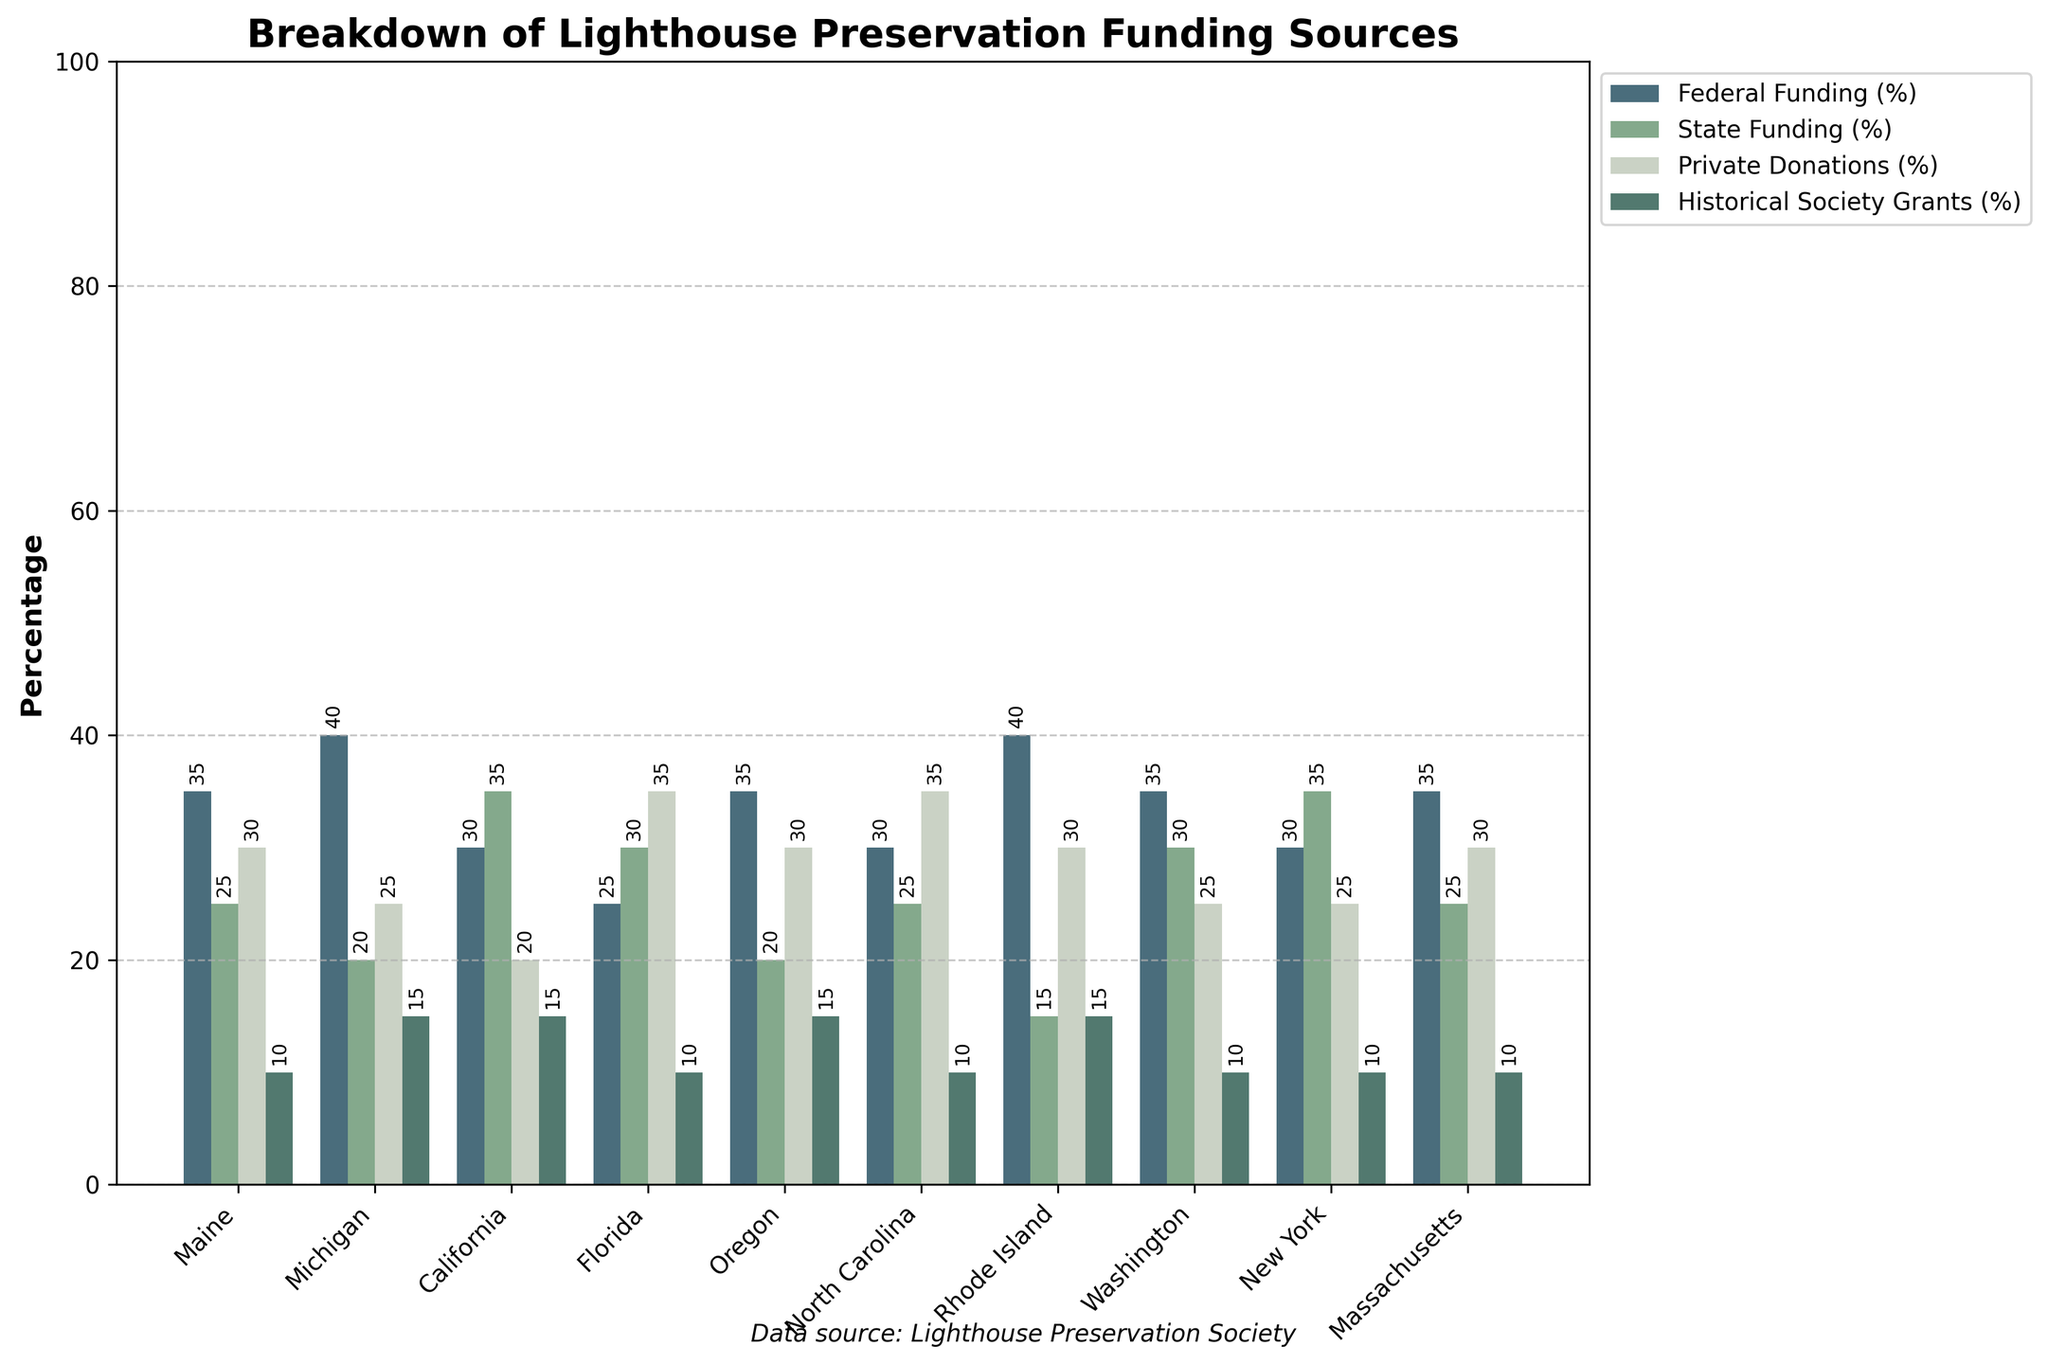What state has the highest percentage of Federal Funding? Refer to the heights of the bars associated with Federal Funding for each state. The highest bar indicates the state with the highest percentage.
Answer: Michigan and Rhode Island Which funding source contributes the least across all states? Observe the color-coded bars. The light green bars, representing Historical Society Grants, tend to be the lowest in height across the board.
Answer: Historical Society Grants Compare the Federal Funding percentage between Maine and Oregon. Which state has a higher percentage? Look at the height of the bars for Federal Funding in Maine and Oregon. The taller bar will indicate the higher percentage.
Answer: They are the same (35%) Which state relies most on Private Donations for lighthouse preservation funding? Check the light blue bars representing Private Donations. The tallest bar will indicate the state that relies most on this funding source.
Answer: Florida and North Carolina What is the combined percentage of State Funding and Private Donations in California? Identify the bars for State Funding and Private Donations in California, sum their heights. State Funding (35%) + Private Donations (20%) = 55%
Answer: 55% How does State Funding in Washington compare with New York? Evaluate the height of the light green bars for these states. Washington and New York both have similar State Funding of 30% and 35% respectively.
Answer: New York has more What is the most common percentage range for State Funding across all states? Look across all light green bars to identify the most frequent percentage range. Most bars are at 25-35%.
Answer: 25-35% Between Oregon and Massachusetts, which state has a higher percentage of Historical Society Grants? Compare the dark green bars for these states. The taller bar will indicate the higher percentage.
Answer: Oregon Calculate the Average Federal Funding Percentage for all states? Sum all Federal Funding percentages and then divide by the number of states: (35+40+30+25+35+30+40+35+30+35)/10 = 33.5%
Answer: 33.5% Are there any states with an equal percentage for any two funding sources? If yes, name one. Check the bar heights for each state to see if two bars are of equal height.
Answer: No states 